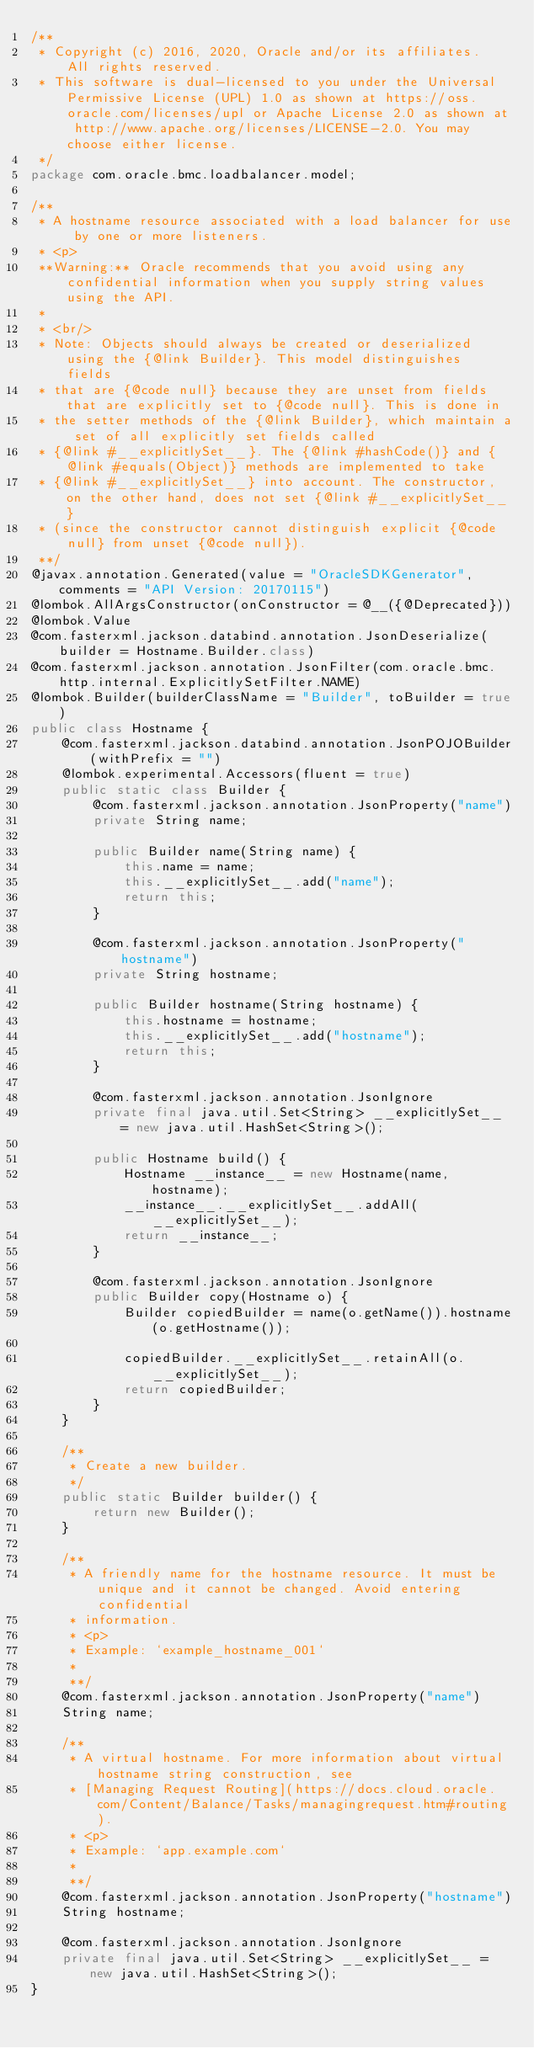Convert code to text. <code><loc_0><loc_0><loc_500><loc_500><_Java_>/**
 * Copyright (c) 2016, 2020, Oracle and/or its affiliates.  All rights reserved.
 * This software is dual-licensed to you under the Universal Permissive License (UPL) 1.0 as shown at https://oss.oracle.com/licenses/upl or Apache License 2.0 as shown at http://www.apache.org/licenses/LICENSE-2.0. You may choose either license.
 */
package com.oracle.bmc.loadbalancer.model;

/**
 * A hostname resource associated with a load balancer for use by one or more listeners.
 * <p>
 **Warning:** Oracle recommends that you avoid using any confidential information when you supply string values using the API.
 *
 * <br/>
 * Note: Objects should always be created or deserialized using the {@link Builder}. This model distinguishes fields
 * that are {@code null} because they are unset from fields that are explicitly set to {@code null}. This is done in
 * the setter methods of the {@link Builder}, which maintain a set of all explicitly set fields called
 * {@link #__explicitlySet__}. The {@link #hashCode()} and {@link #equals(Object)} methods are implemented to take
 * {@link #__explicitlySet__} into account. The constructor, on the other hand, does not set {@link #__explicitlySet__}
 * (since the constructor cannot distinguish explicit {@code null} from unset {@code null}).
 **/
@javax.annotation.Generated(value = "OracleSDKGenerator", comments = "API Version: 20170115")
@lombok.AllArgsConstructor(onConstructor = @__({@Deprecated}))
@lombok.Value
@com.fasterxml.jackson.databind.annotation.JsonDeserialize(builder = Hostname.Builder.class)
@com.fasterxml.jackson.annotation.JsonFilter(com.oracle.bmc.http.internal.ExplicitlySetFilter.NAME)
@lombok.Builder(builderClassName = "Builder", toBuilder = true)
public class Hostname {
    @com.fasterxml.jackson.databind.annotation.JsonPOJOBuilder(withPrefix = "")
    @lombok.experimental.Accessors(fluent = true)
    public static class Builder {
        @com.fasterxml.jackson.annotation.JsonProperty("name")
        private String name;

        public Builder name(String name) {
            this.name = name;
            this.__explicitlySet__.add("name");
            return this;
        }

        @com.fasterxml.jackson.annotation.JsonProperty("hostname")
        private String hostname;

        public Builder hostname(String hostname) {
            this.hostname = hostname;
            this.__explicitlySet__.add("hostname");
            return this;
        }

        @com.fasterxml.jackson.annotation.JsonIgnore
        private final java.util.Set<String> __explicitlySet__ = new java.util.HashSet<String>();

        public Hostname build() {
            Hostname __instance__ = new Hostname(name, hostname);
            __instance__.__explicitlySet__.addAll(__explicitlySet__);
            return __instance__;
        }

        @com.fasterxml.jackson.annotation.JsonIgnore
        public Builder copy(Hostname o) {
            Builder copiedBuilder = name(o.getName()).hostname(o.getHostname());

            copiedBuilder.__explicitlySet__.retainAll(o.__explicitlySet__);
            return copiedBuilder;
        }
    }

    /**
     * Create a new builder.
     */
    public static Builder builder() {
        return new Builder();
    }

    /**
     * A friendly name for the hostname resource. It must be unique and it cannot be changed. Avoid entering confidential
     * information.
     * <p>
     * Example: `example_hostname_001`
     *
     **/
    @com.fasterxml.jackson.annotation.JsonProperty("name")
    String name;

    /**
     * A virtual hostname. For more information about virtual hostname string construction, see
     * [Managing Request Routing](https://docs.cloud.oracle.com/Content/Balance/Tasks/managingrequest.htm#routing).
     * <p>
     * Example: `app.example.com`
     *
     **/
    @com.fasterxml.jackson.annotation.JsonProperty("hostname")
    String hostname;

    @com.fasterxml.jackson.annotation.JsonIgnore
    private final java.util.Set<String> __explicitlySet__ = new java.util.HashSet<String>();
}
</code> 